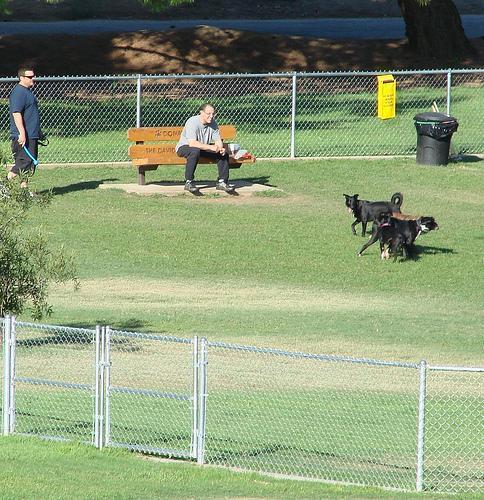How many dogs are there?
Give a very brief answer. 3. How many people are wearing sunglasses?
Give a very brief answer. 1. 